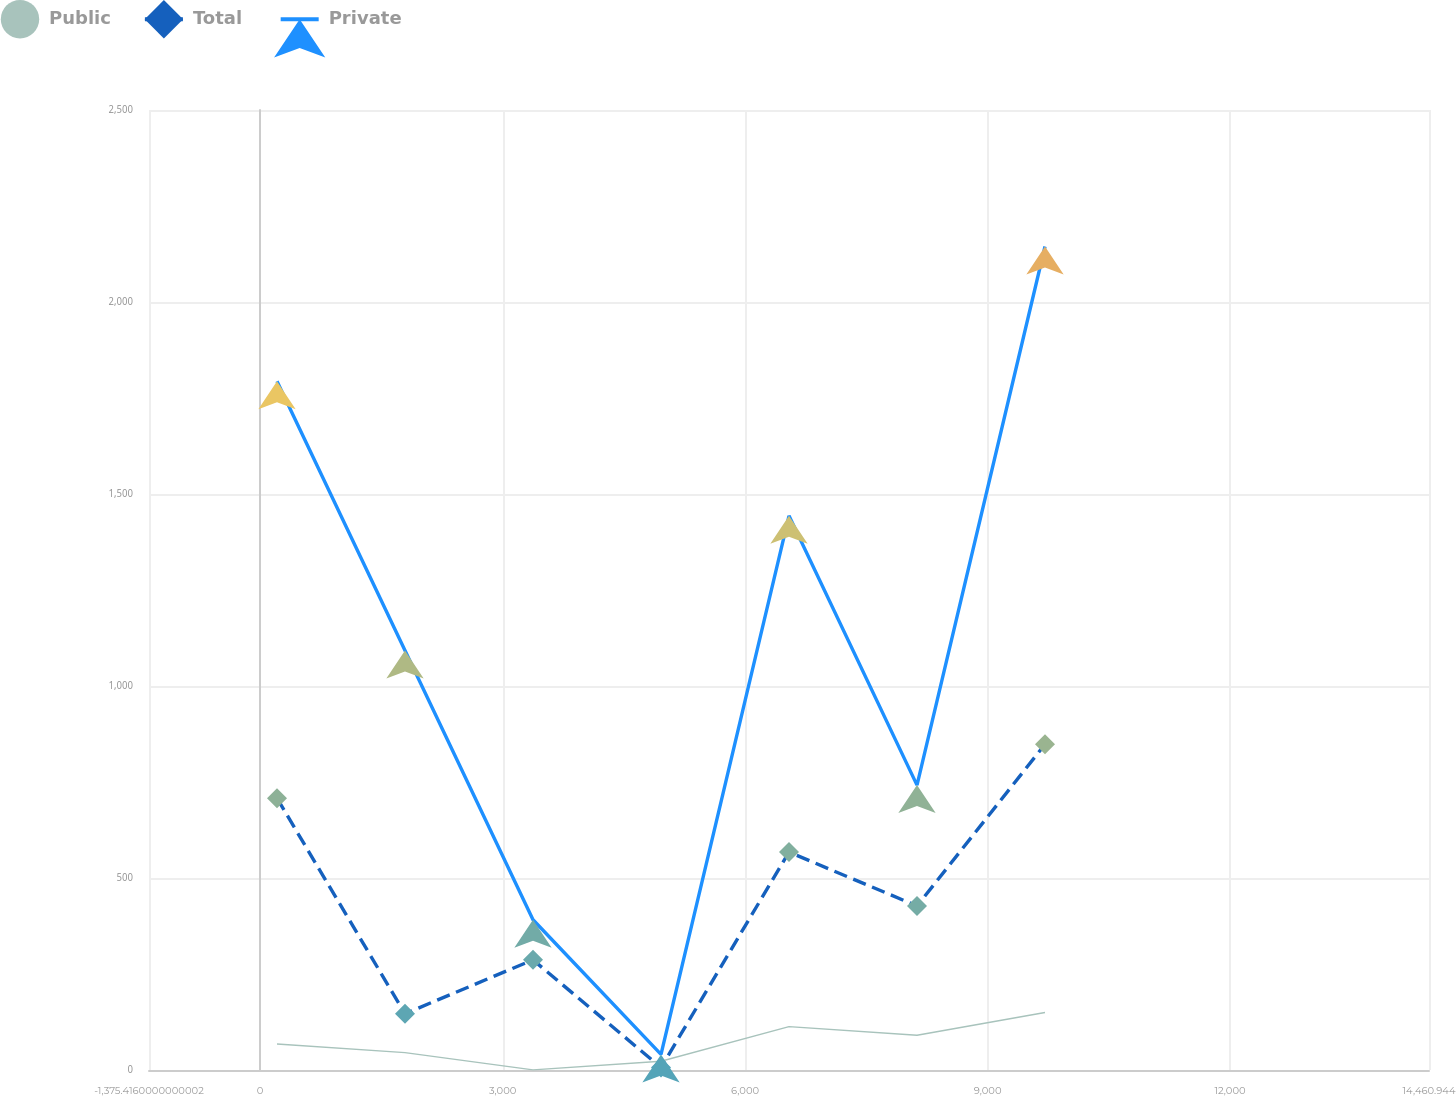Convert chart to OTSL. <chart><loc_0><loc_0><loc_500><loc_500><line_chart><ecel><fcel>Public<fcel>Total<fcel>Private<nl><fcel>208.22<fcel>67.82<fcel>707.81<fcel>1793.85<nl><fcel>1791.86<fcel>45.31<fcel>146.57<fcel>1092.55<nl><fcel>3375.5<fcel>0.29<fcel>286.88<fcel>391.25<nl><fcel>4959.14<fcel>22.8<fcel>6.26<fcel>40.6<nl><fcel>6542.78<fcel>112.84<fcel>567.5<fcel>1443.2<nl><fcel>8126.42<fcel>90.33<fcel>427.19<fcel>741.9<nl><fcel>9710.06<fcel>149.63<fcel>848.12<fcel>2144.5<nl><fcel>16044.6<fcel>225.43<fcel>1409.39<fcel>3547.06<nl></chart> 